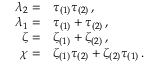<formula> <loc_0><loc_0><loc_500><loc_500>\begin{array} { r l } { \lambda _ { 2 } = } & { \tau _ { ( 1 ) } \tau _ { ( 2 ) } \, , } \\ { \lambda _ { 1 } = } & { \tau _ { ( 1 ) } + \tau _ { ( 2 ) } \, , } \\ { \zeta = } & { \zeta _ { ( 1 ) } + \zeta _ { ( 2 ) } \, , } \\ { \chi = } & { \zeta _ { ( 1 ) } \tau _ { ( 2 ) } + \zeta _ { ( 2 ) } \tau _ { ( 1 ) } \, . } \end{array}</formula> 